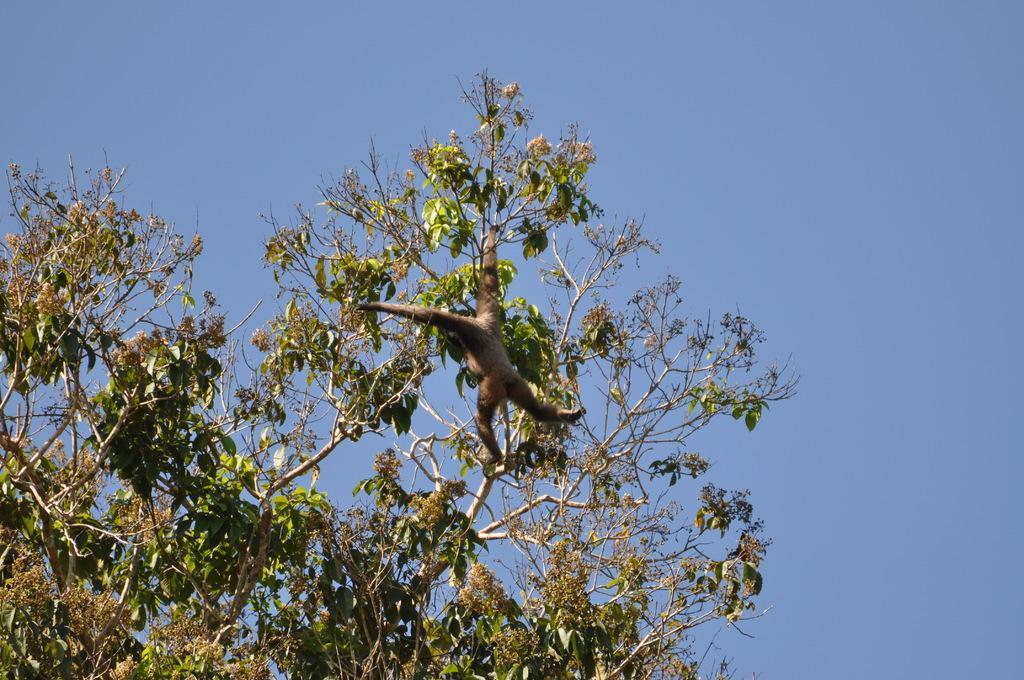Please provide a concise description of this image. In this image there is a monkey on the tree. At the background there is sky. 